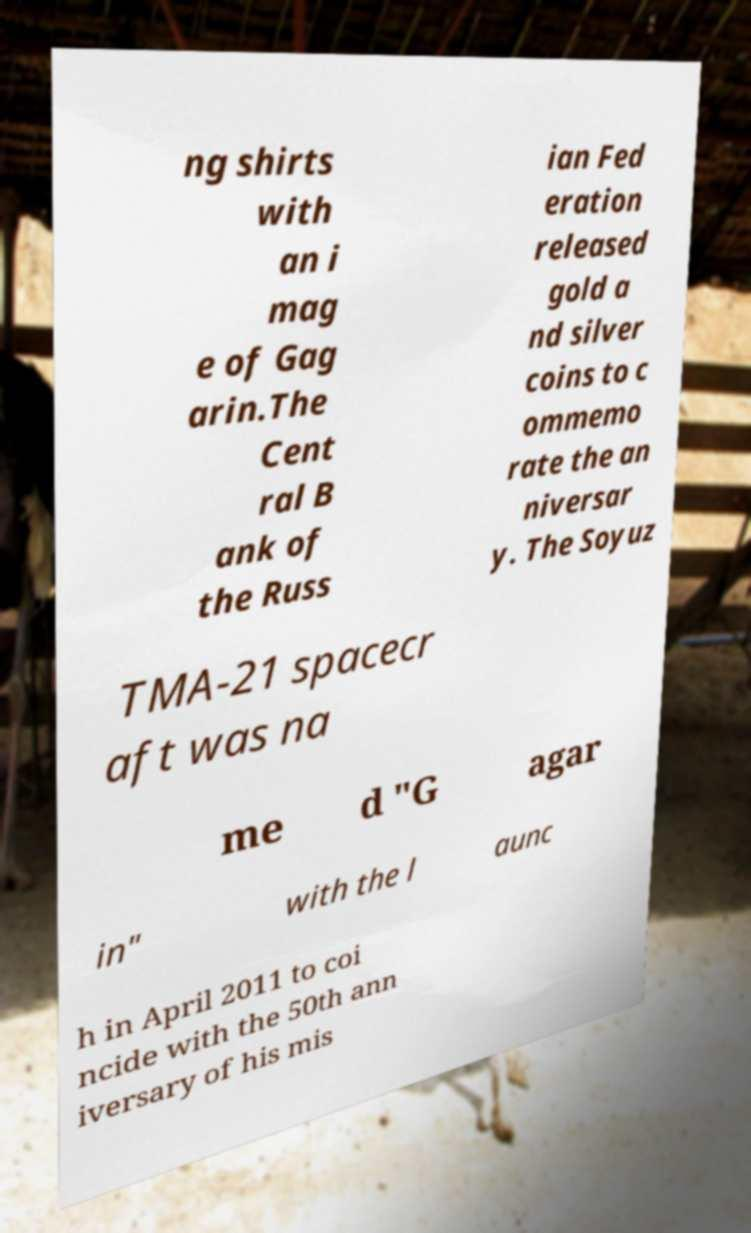Could you extract and type out the text from this image? ng shirts with an i mag e of Gag arin.The Cent ral B ank of the Russ ian Fed eration released gold a nd silver coins to c ommemo rate the an niversar y. The Soyuz TMA-21 spacecr aft was na me d "G agar in" with the l aunc h in April 2011 to coi ncide with the 50th ann iversary of his mis 